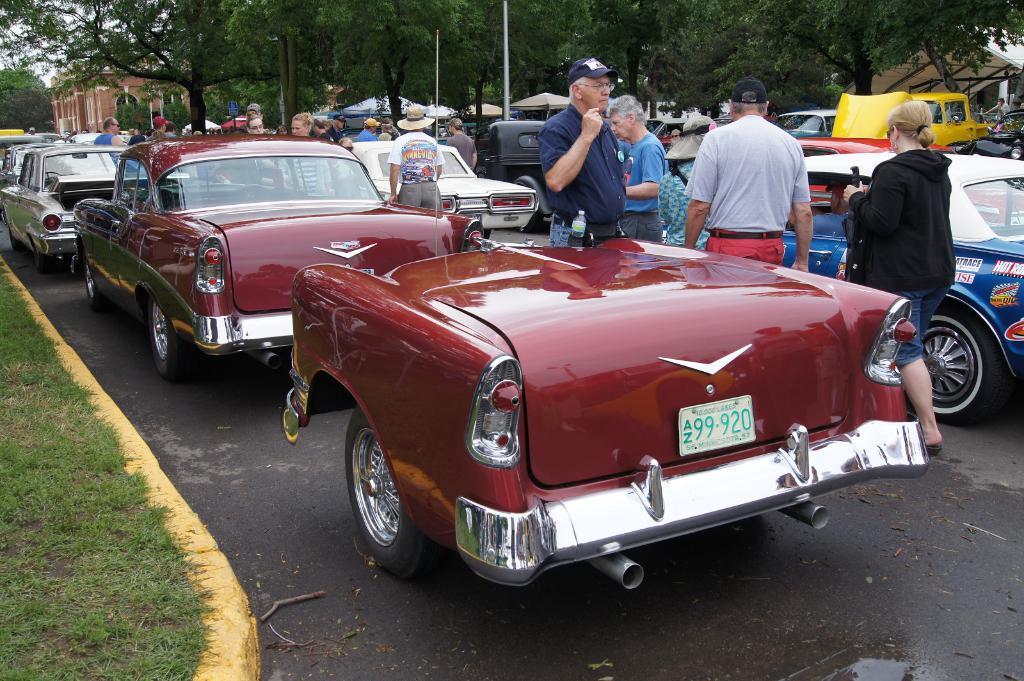Describe this image in one or two sentences. Here we can see vehicles and persons on the road. This is grass. In the background we can see trees, poles, buildings, and sky. 